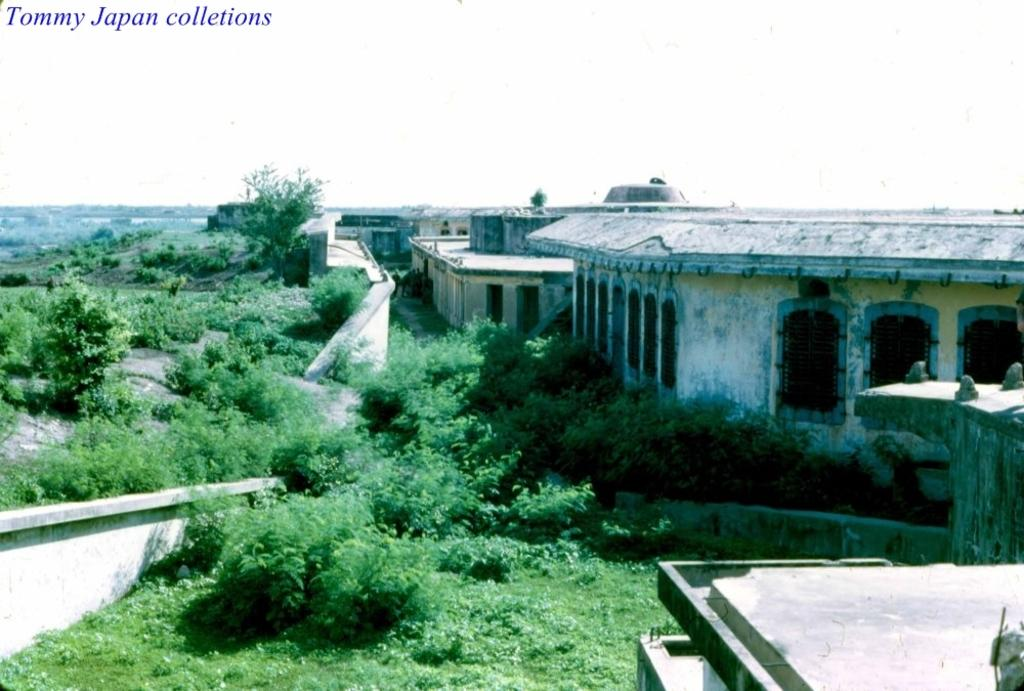What type of structures are located in the center of the image? There are houses in the center of the image. What type of vegetation can be seen in the image? There are trees in the image. What type of ground cover is present in the image? There is grass in the image. What type of ear is visible on the tree in the image? There is no ear present in the image; it features houses, trees, and grass. 